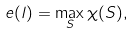Convert formula to latex. <formula><loc_0><loc_0><loc_500><loc_500>e ( l ) = \max _ { S } \chi ( S ) ,</formula> 